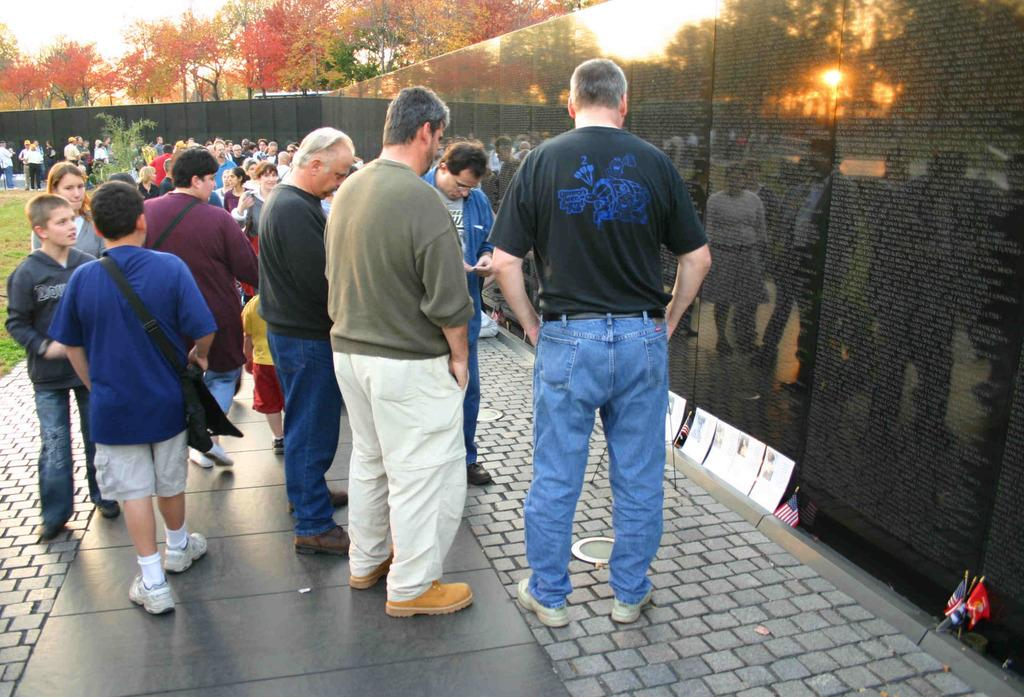What are the people in the image doing? There is a group of people standing on the ground in the image. What can be seen on the wall in the image? There is some text visible on the wall. What objects are visible in the image besides the people and the wall? Papers, flags, plants, and a group of trees are visible in the image. What part of the natural environment is visible in the image? The sky is visible in the image. How many friends are visible in the image? The term "friends" is not mentioned in the provided facts, so it is not possible to answer this question based on the information given. 